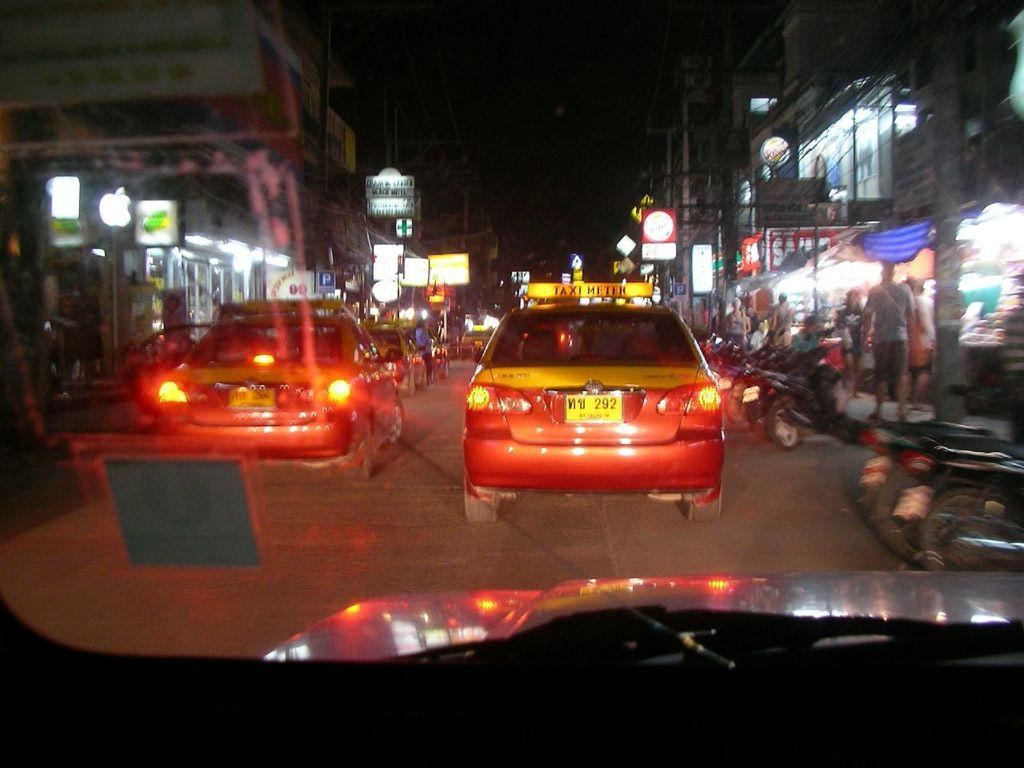<image>
Render a clear and concise summary of the photo. A car on a city street has the number 292 on its plate. 